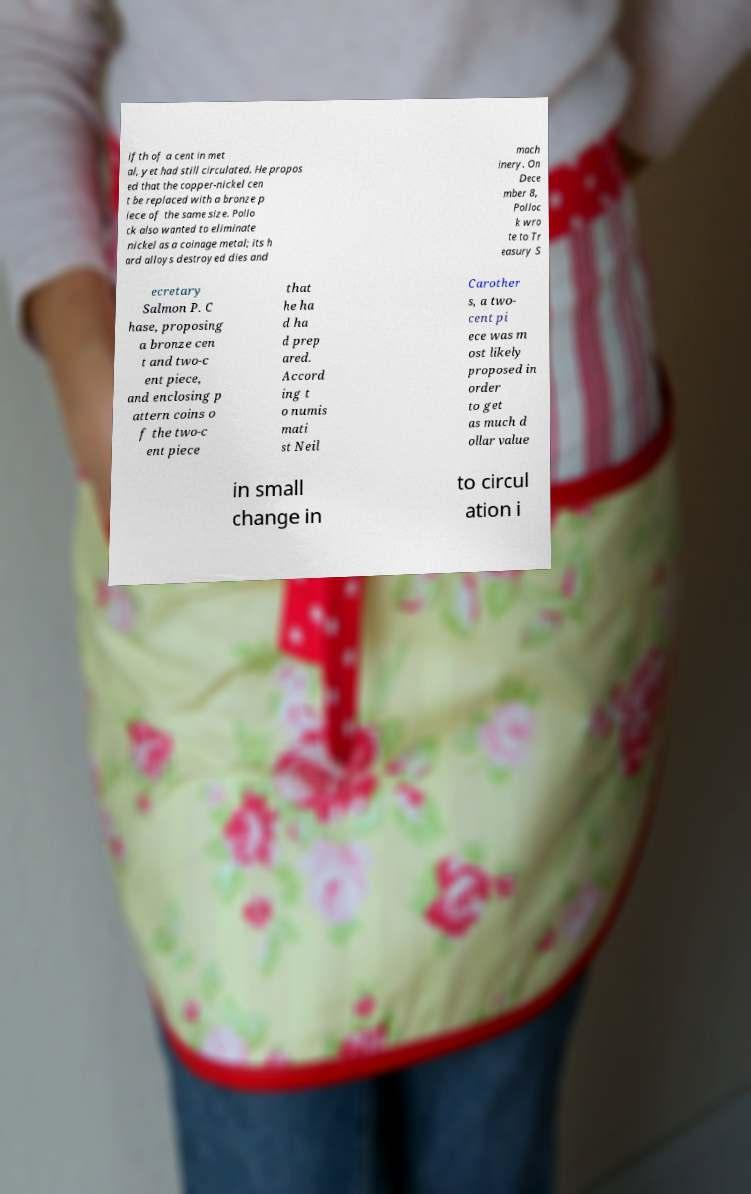There's text embedded in this image that I need extracted. Can you transcribe it verbatim? ifth of a cent in met al, yet had still circulated. He propos ed that the copper-nickel cen t be replaced with a bronze p iece of the same size. Pollo ck also wanted to eliminate nickel as a coinage metal; its h ard alloys destroyed dies and mach inery. On Dece mber 8, Polloc k wro te to Tr easury S ecretary Salmon P. C hase, proposing a bronze cen t and two-c ent piece, and enclosing p attern coins o f the two-c ent piece that he ha d ha d prep ared. Accord ing t o numis mati st Neil Carother s, a two- cent pi ece was m ost likely proposed in order to get as much d ollar value in small change in to circul ation i 